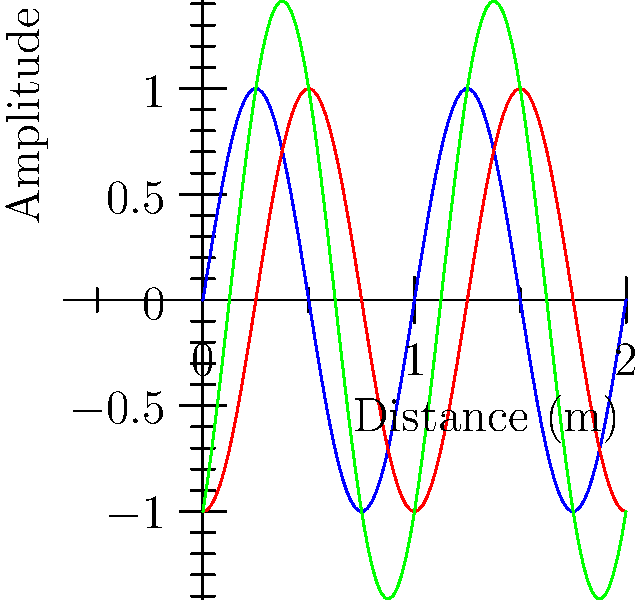In your club setup, two speakers are placed 0.25 meters apart, both emitting identical sine waves with a wavelength of 1 meter. Based on the graph showing the individual waves (blue and red) and their interference pattern (green), at what distance(s) from the first speaker would a club-goer experience maximum sound intensity? To solve this problem, we need to follow these steps:

1. Understand the wave interference:
   - The blue line represents the wave from Speaker 1
   - The red line represents the wave from Speaker 2 (shifted by 0.25m)
   - The green line shows the resultant interference pattern

2. Identify constructive interference:
   - Maximum sound intensity occurs at points of constructive interference
   - This happens when the peaks of both waves align

3. Analyze the graph:
   - The first maximum occurs at x = 0m (start of the graph)
   - The next maximum occurs at x = 0.5m
   - This pattern repeats every 0.5m

4. Explain the pattern:
   - The wavelength is 1m, so a phase difference of 0.5m (half a wavelength) causes the waves to realign
   - The 0.25m speaker separation causes a 0.25m initial offset, which is compensated every 0.5m

5. Formulate the answer:
   - Maxima occur at distances of 0m, 0.5m, 1m, 1.5m, and so on from the first speaker
   - This can be expressed as $n \times 0.5m$, where $n$ is any non-negative integer

Therefore, club-goers will experience maximum sound intensity at regular intervals of 0.5 meters from the first speaker.
Answer: $n \times 0.5m$, where $n$ is any non-negative integer 